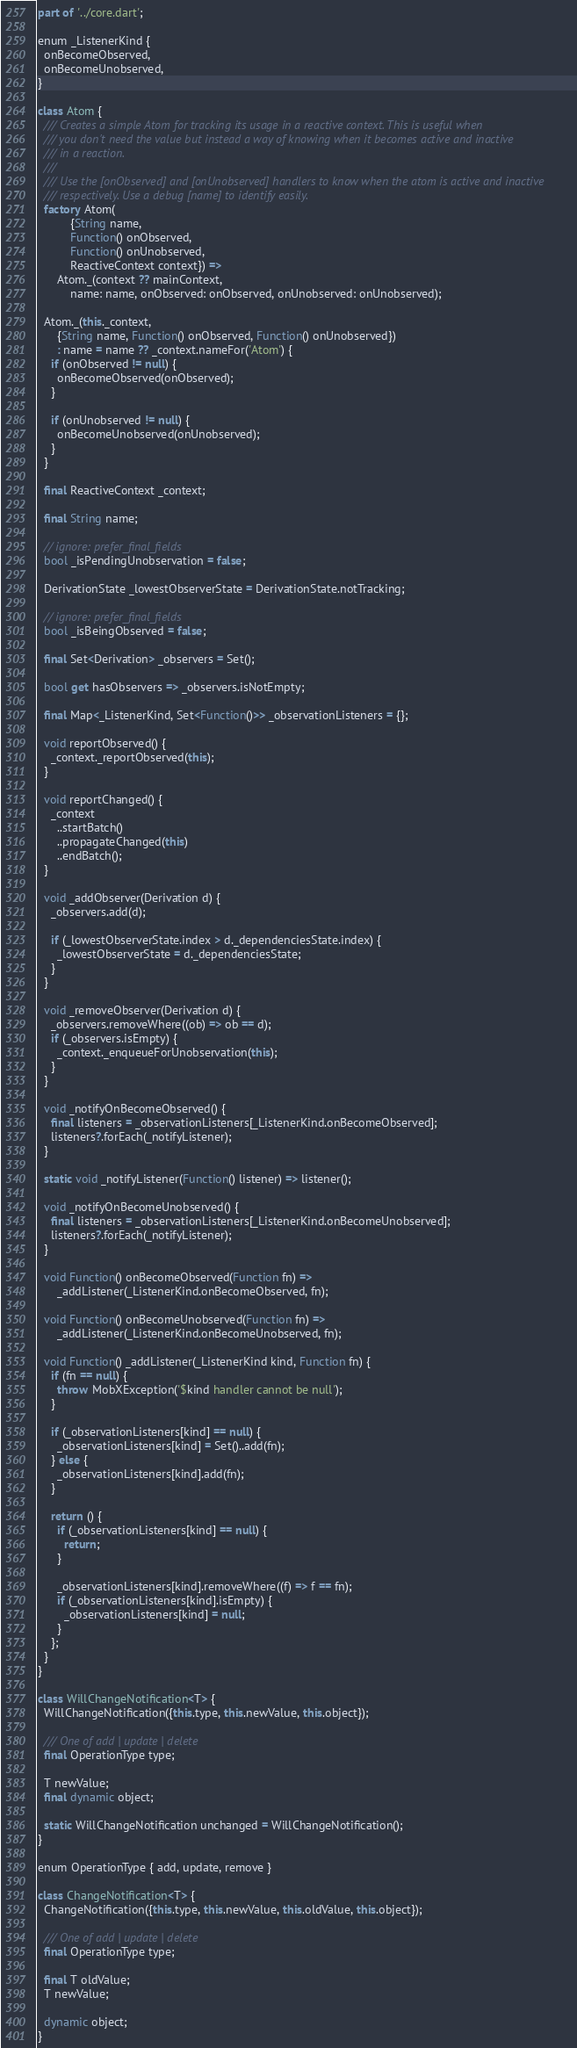<code> <loc_0><loc_0><loc_500><loc_500><_Dart_>part of '../core.dart';

enum _ListenerKind {
  onBecomeObserved,
  onBecomeUnobserved,
}

class Atom {
  /// Creates a simple Atom for tracking its usage in a reactive context. This is useful when
  /// you don't need the value but instead a way of knowing when it becomes active and inactive
  /// in a reaction.
  ///
  /// Use the [onObserved] and [onUnobserved] handlers to know when the atom is active and inactive
  /// respectively. Use a debug [name] to identify easily.
  factory Atom(
          {String name,
          Function() onObserved,
          Function() onUnobserved,
          ReactiveContext context}) =>
      Atom._(context ?? mainContext,
          name: name, onObserved: onObserved, onUnobserved: onUnobserved);

  Atom._(this._context,
      {String name, Function() onObserved, Function() onUnobserved})
      : name = name ?? _context.nameFor('Atom') {
    if (onObserved != null) {
      onBecomeObserved(onObserved);
    }

    if (onUnobserved != null) {
      onBecomeUnobserved(onUnobserved);
    }
  }

  final ReactiveContext _context;

  final String name;

  // ignore: prefer_final_fields
  bool _isPendingUnobservation = false;

  DerivationState _lowestObserverState = DerivationState.notTracking;

  // ignore: prefer_final_fields
  bool _isBeingObserved = false;

  final Set<Derivation> _observers = Set();

  bool get hasObservers => _observers.isNotEmpty;

  final Map<_ListenerKind, Set<Function()>> _observationListeners = {};

  void reportObserved() {
    _context._reportObserved(this);
  }

  void reportChanged() {
    _context
      ..startBatch()
      ..propagateChanged(this)
      ..endBatch();
  }

  void _addObserver(Derivation d) {
    _observers.add(d);

    if (_lowestObserverState.index > d._dependenciesState.index) {
      _lowestObserverState = d._dependenciesState;
    }
  }

  void _removeObserver(Derivation d) {
    _observers.removeWhere((ob) => ob == d);
    if (_observers.isEmpty) {
      _context._enqueueForUnobservation(this);
    }
  }

  void _notifyOnBecomeObserved() {
    final listeners = _observationListeners[_ListenerKind.onBecomeObserved];
    listeners?.forEach(_notifyListener);
  }

  static void _notifyListener(Function() listener) => listener();

  void _notifyOnBecomeUnobserved() {
    final listeners = _observationListeners[_ListenerKind.onBecomeUnobserved];
    listeners?.forEach(_notifyListener);
  }

  void Function() onBecomeObserved(Function fn) =>
      _addListener(_ListenerKind.onBecomeObserved, fn);

  void Function() onBecomeUnobserved(Function fn) =>
      _addListener(_ListenerKind.onBecomeUnobserved, fn);

  void Function() _addListener(_ListenerKind kind, Function fn) {
    if (fn == null) {
      throw MobXException('$kind handler cannot be null');
    }

    if (_observationListeners[kind] == null) {
      _observationListeners[kind] = Set()..add(fn);
    } else {
      _observationListeners[kind].add(fn);
    }

    return () {
      if (_observationListeners[kind] == null) {
        return;
      }

      _observationListeners[kind].removeWhere((f) => f == fn);
      if (_observationListeners[kind].isEmpty) {
        _observationListeners[kind] = null;
      }
    };
  }
}

class WillChangeNotification<T> {
  WillChangeNotification({this.type, this.newValue, this.object});

  /// One of add | update | delete
  final OperationType type;

  T newValue;
  final dynamic object;

  static WillChangeNotification unchanged = WillChangeNotification();
}

enum OperationType { add, update, remove }

class ChangeNotification<T> {
  ChangeNotification({this.type, this.newValue, this.oldValue, this.object});

  /// One of add | update | delete
  final OperationType type;

  final T oldValue;
  T newValue;

  dynamic object;
}
</code> 